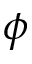<formula> <loc_0><loc_0><loc_500><loc_500>\phi</formula> 